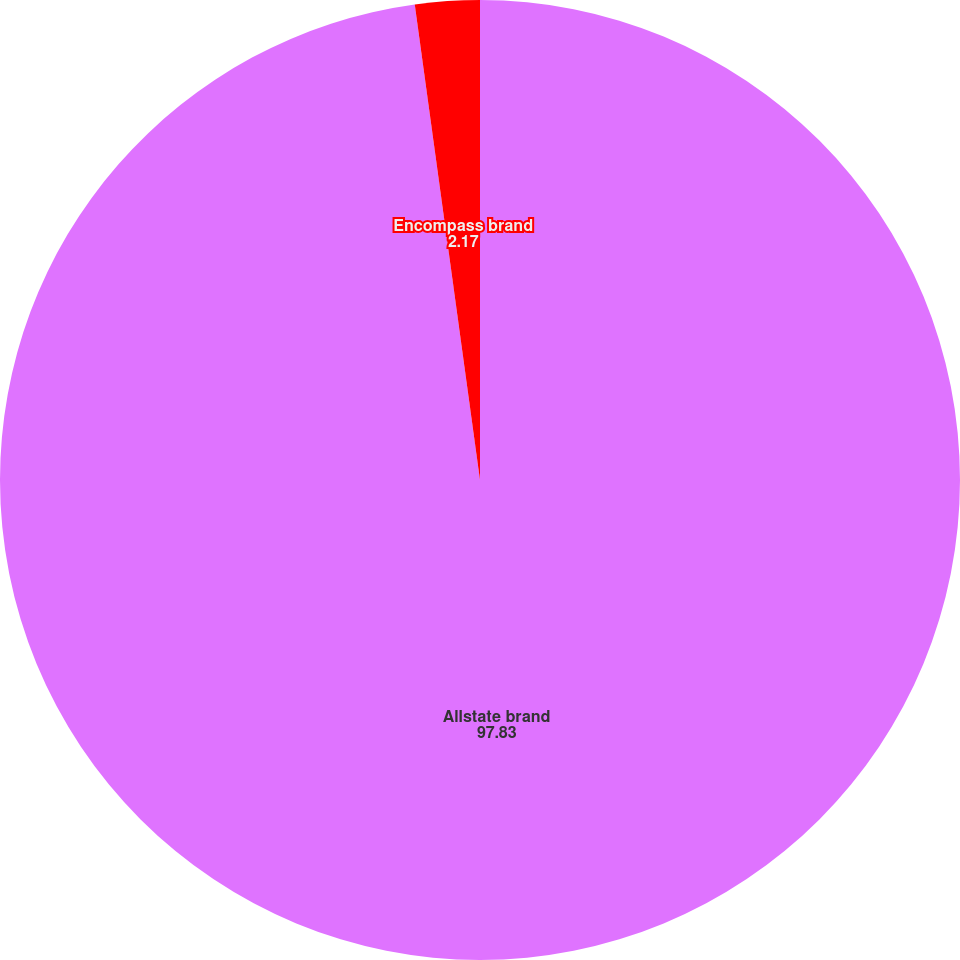Convert chart. <chart><loc_0><loc_0><loc_500><loc_500><pie_chart><fcel>Allstate brand<fcel>Encompass brand<nl><fcel>97.83%<fcel>2.17%<nl></chart> 